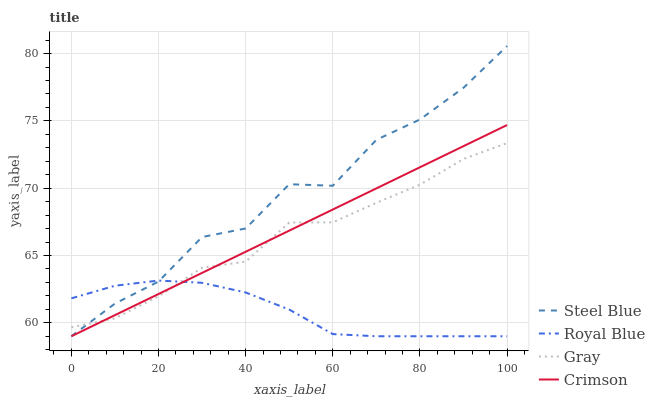Does Royal Blue have the minimum area under the curve?
Answer yes or no. Yes. Does Steel Blue have the maximum area under the curve?
Answer yes or no. Yes. Does Steel Blue have the minimum area under the curve?
Answer yes or no. No. Does Royal Blue have the maximum area under the curve?
Answer yes or no. No. Is Crimson the smoothest?
Answer yes or no. Yes. Is Steel Blue the roughest?
Answer yes or no. Yes. Is Royal Blue the smoothest?
Answer yes or no. No. Is Royal Blue the roughest?
Answer yes or no. No. Does Crimson have the lowest value?
Answer yes or no. Yes. Does Gray have the lowest value?
Answer yes or no. No. Does Steel Blue have the highest value?
Answer yes or no. Yes. Does Royal Blue have the highest value?
Answer yes or no. No. Does Gray intersect Steel Blue?
Answer yes or no. Yes. Is Gray less than Steel Blue?
Answer yes or no. No. Is Gray greater than Steel Blue?
Answer yes or no. No. 